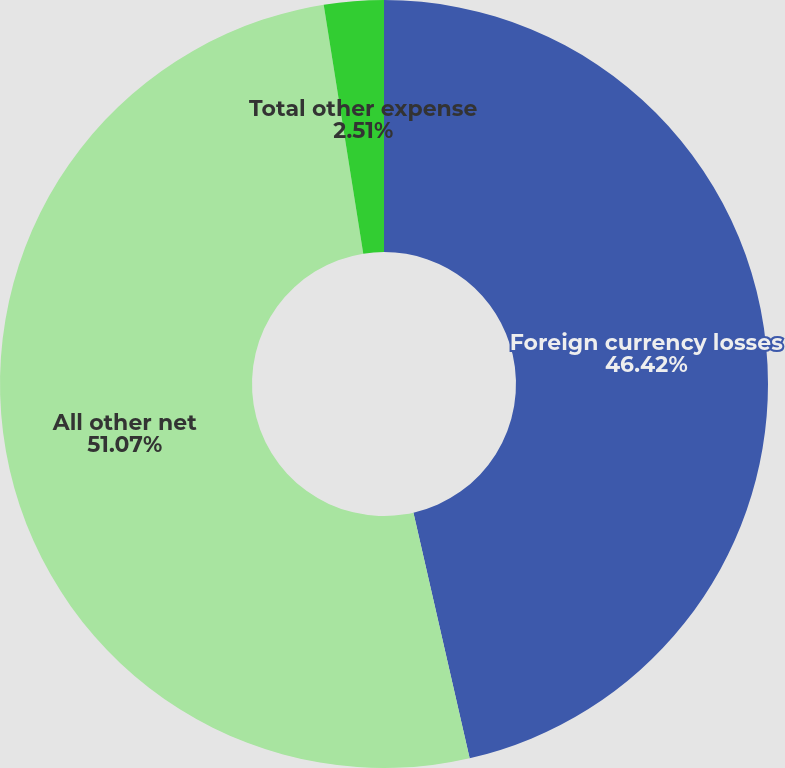Convert chart. <chart><loc_0><loc_0><loc_500><loc_500><pie_chart><fcel>Foreign currency losses<fcel>All other net<fcel>Total other expense<nl><fcel>46.42%<fcel>51.07%<fcel>2.51%<nl></chart> 